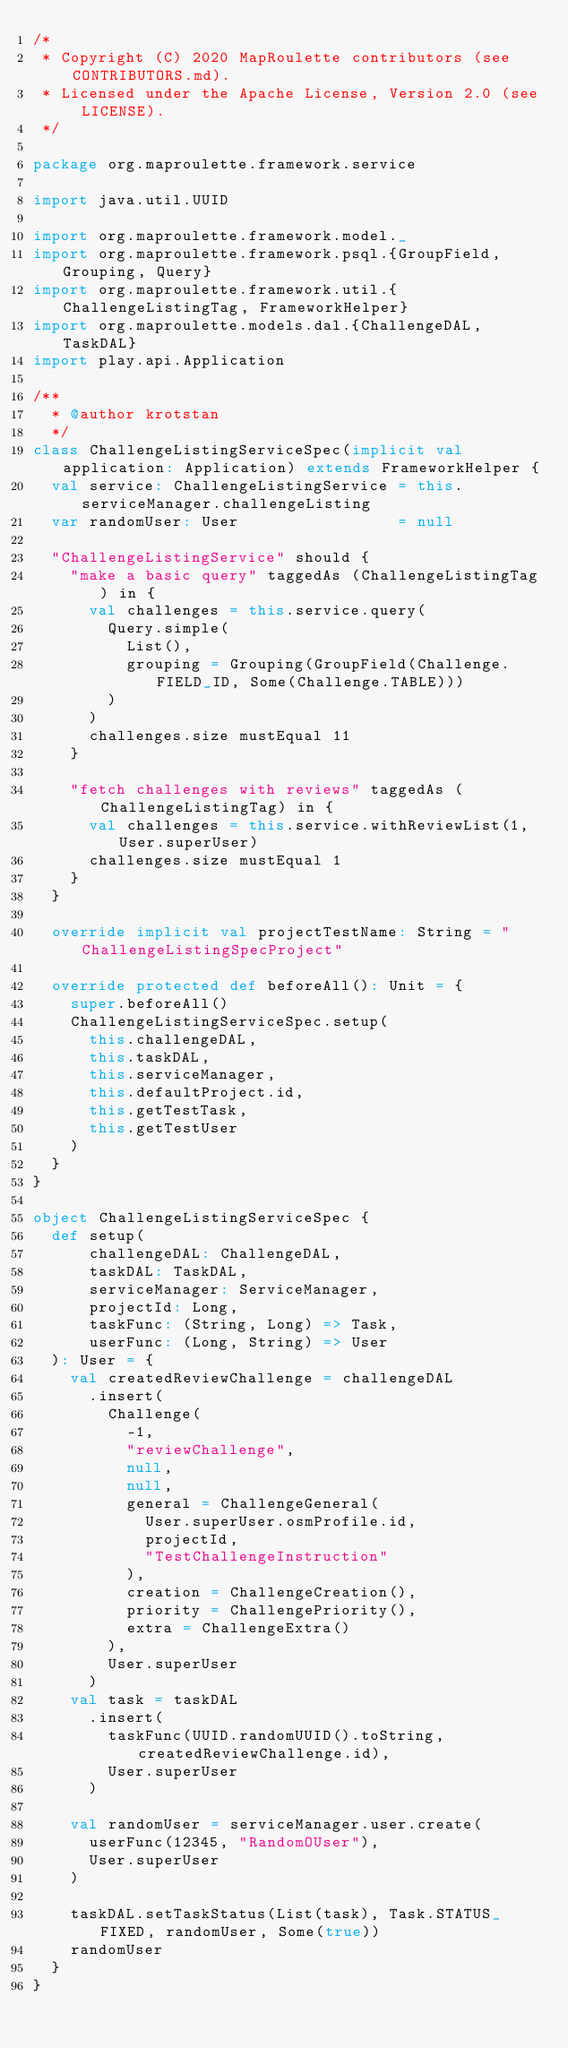<code> <loc_0><loc_0><loc_500><loc_500><_Scala_>/*
 * Copyright (C) 2020 MapRoulette contributors (see CONTRIBUTORS.md).
 * Licensed under the Apache License, Version 2.0 (see LICENSE).
 */

package org.maproulette.framework.service

import java.util.UUID

import org.maproulette.framework.model._
import org.maproulette.framework.psql.{GroupField, Grouping, Query}
import org.maproulette.framework.util.{ChallengeListingTag, FrameworkHelper}
import org.maproulette.models.dal.{ChallengeDAL, TaskDAL}
import play.api.Application

/**
  * @author krotstan
  */
class ChallengeListingServiceSpec(implicit val application: Application) extends FrameworkHelper {
  val service: ChallengeListingService = this.serviceManager.challengeListing
  var randomUser: User                 = null

  "ChallengeListingService" should {
    "make a basic query" taggedAs (ChallengeListingTag) in {
      val challenges = this.service.query(
        Query.simple(
          List(),
          grouping = Grouping(GroupField(Challenge.FIELD_ID, Some(Challenge.TABLE)))
        )
      )
      challenges.size mustEqual 11
    }

    "fetch challenges with reviews" taggedAs (ChallengeListingTag) in {
      val challenges = this.service.withReviewList(1, User.superUser)
      challenges.size mustEqual 1
    }
  }

  override implicit val projectTestName: String = "ChallengeListingSpecProject"

  override protected def beforeAll(): Unit = {
    super.beforeAll()
    ChallengeListingServiceSpec.setup(
      this.challengeDAL,
      this.taskDAL,
      this.serviceManager,
      this.defaultProject.id,
      this.getTestTask,
      this.getTestUser
    )
  }
}

object ChallengeListingServiceSpec {
  def setup(
      challengeDAL: ChallengeDAL,
      taskDAL: TaskDAL,
      serviceManager: ServiceManager,
      projectId: Long,
      taskFunc: (String, Long) => Task,
      userFunc: (Long, String) => User
  ): User = {
    val createdReviewChallenge = challengeDAL
      .insert(
        Challenge(
          -1,
          "reviewChallenge",
          null,
          null,
          general = ChallengeGeneral(
            User.superUser.osmProfile.id,
            projectId,
            "TestChallengeInstruction"
          ),
          creation = ChallengeCreation(),
          priority = ChallengePriority(),
          extra = ChallengeExtra()
        ),
        User.superUser
      )
    val task = taskDAL
      .insert(
        taskFunc(UUID.randomUUID().toString, createdReviewChallenge.id),
        User.superUser
      )

    val randomUser = serviceManager.user.create(
      userFunc(12345, "RandomOUser"),
      User.superUser
    )

    taskDAL.setTaskStatus(List(task), Task.STATUS_FIXED, randomUser, Some(true))
    randomUser
  }
}
</code> 